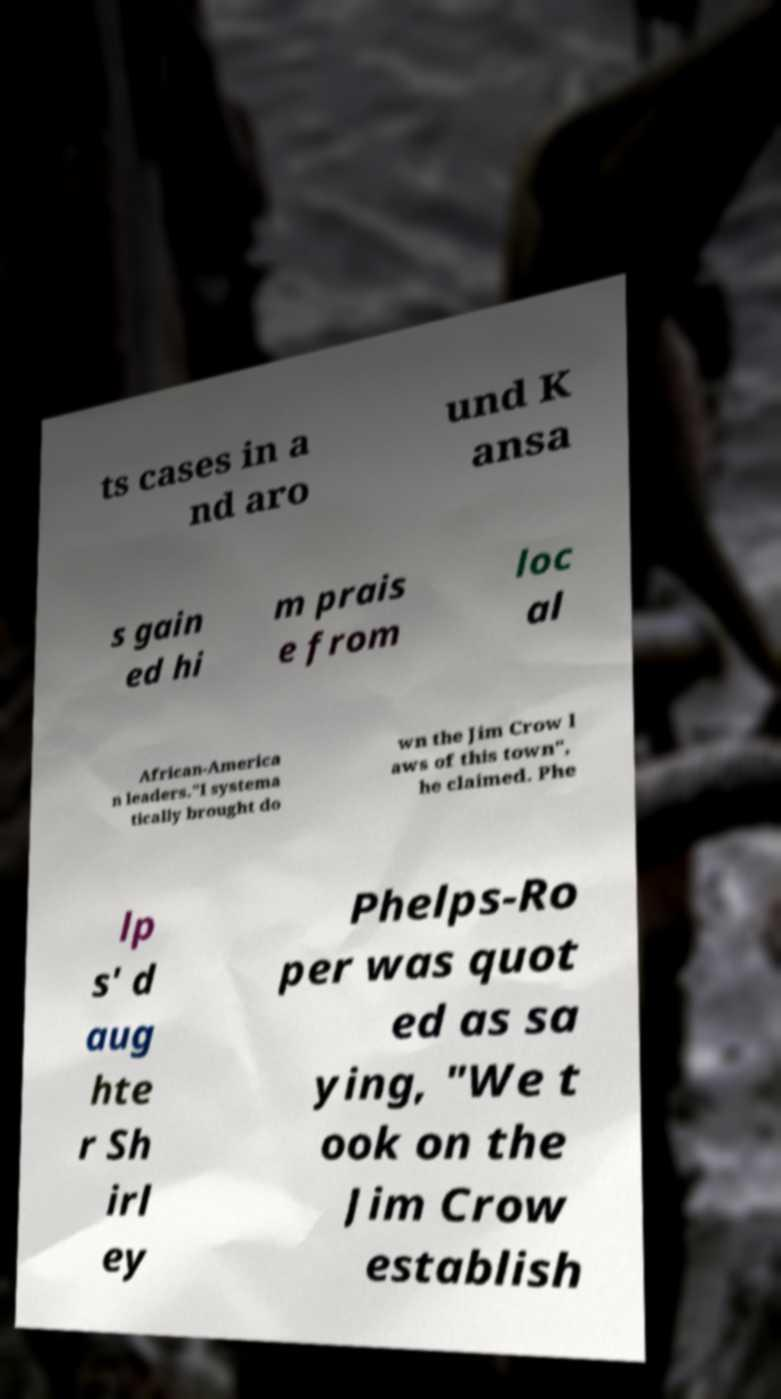There's text embedded in this image that I need extracted. Can you transcribe it verbatim? ts cases in a nd aro und K ansa s gain ed hi m prais e from loc al African-America n leaders."I systema tically brought do wn the Jim Crow l aws of this town", he claimed. Phe lp s' d aug hte r Sh irl ey Phelps-Ro per was quot ed as sa ying, "We t ook on the Jim Crow establish 